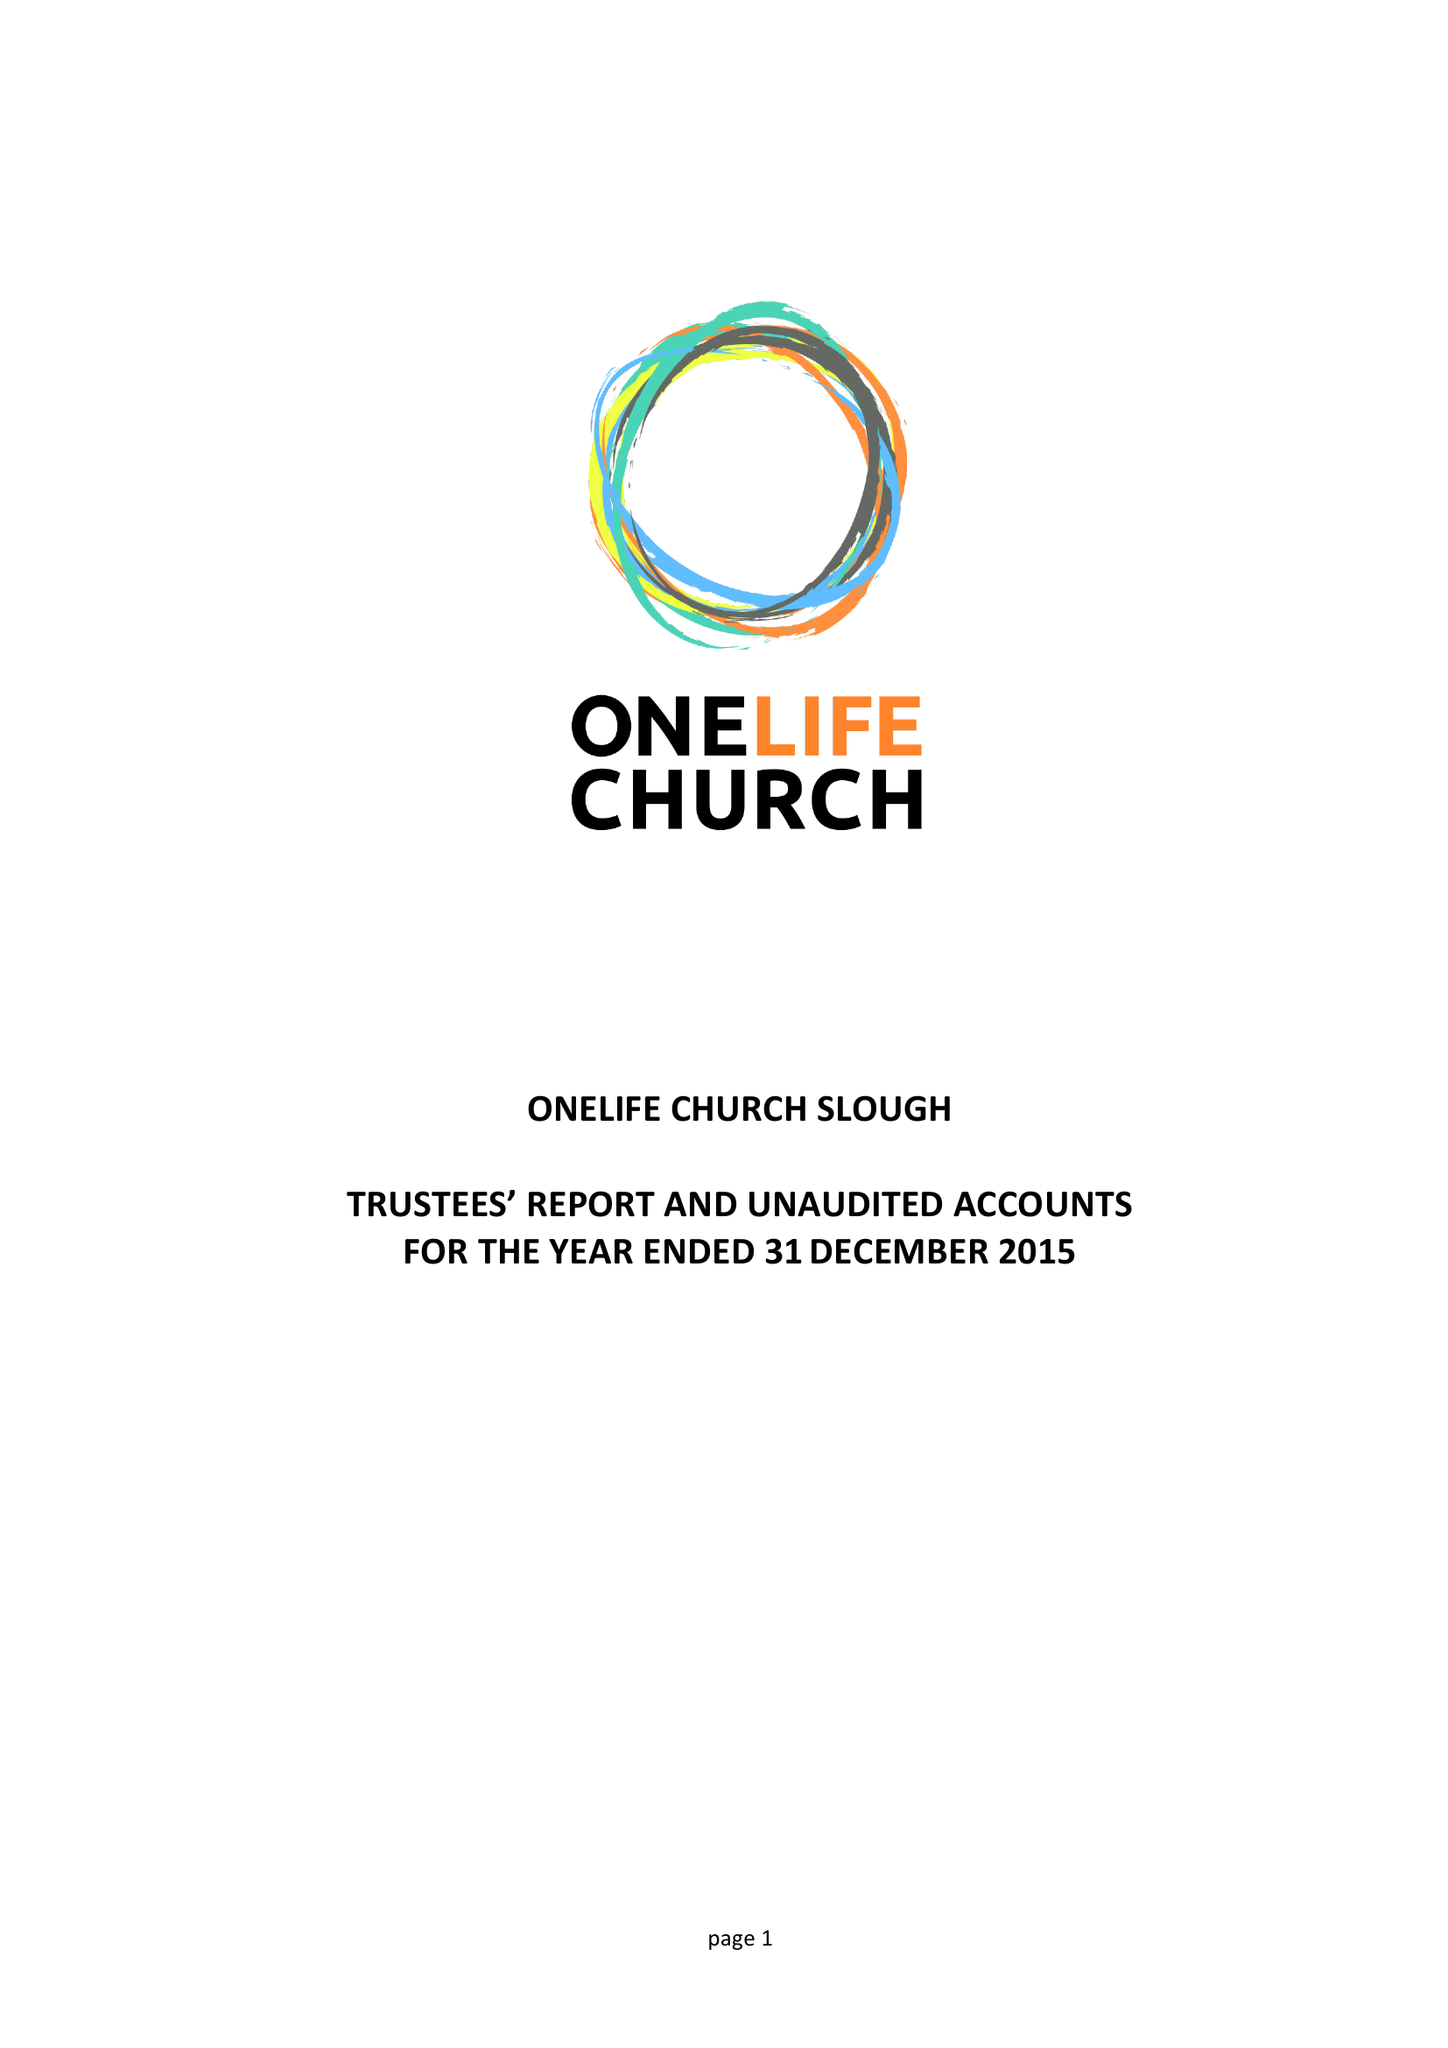What is the value for the charity_name?
Answer the question using a single word or phrase. Onelife Church Slough 